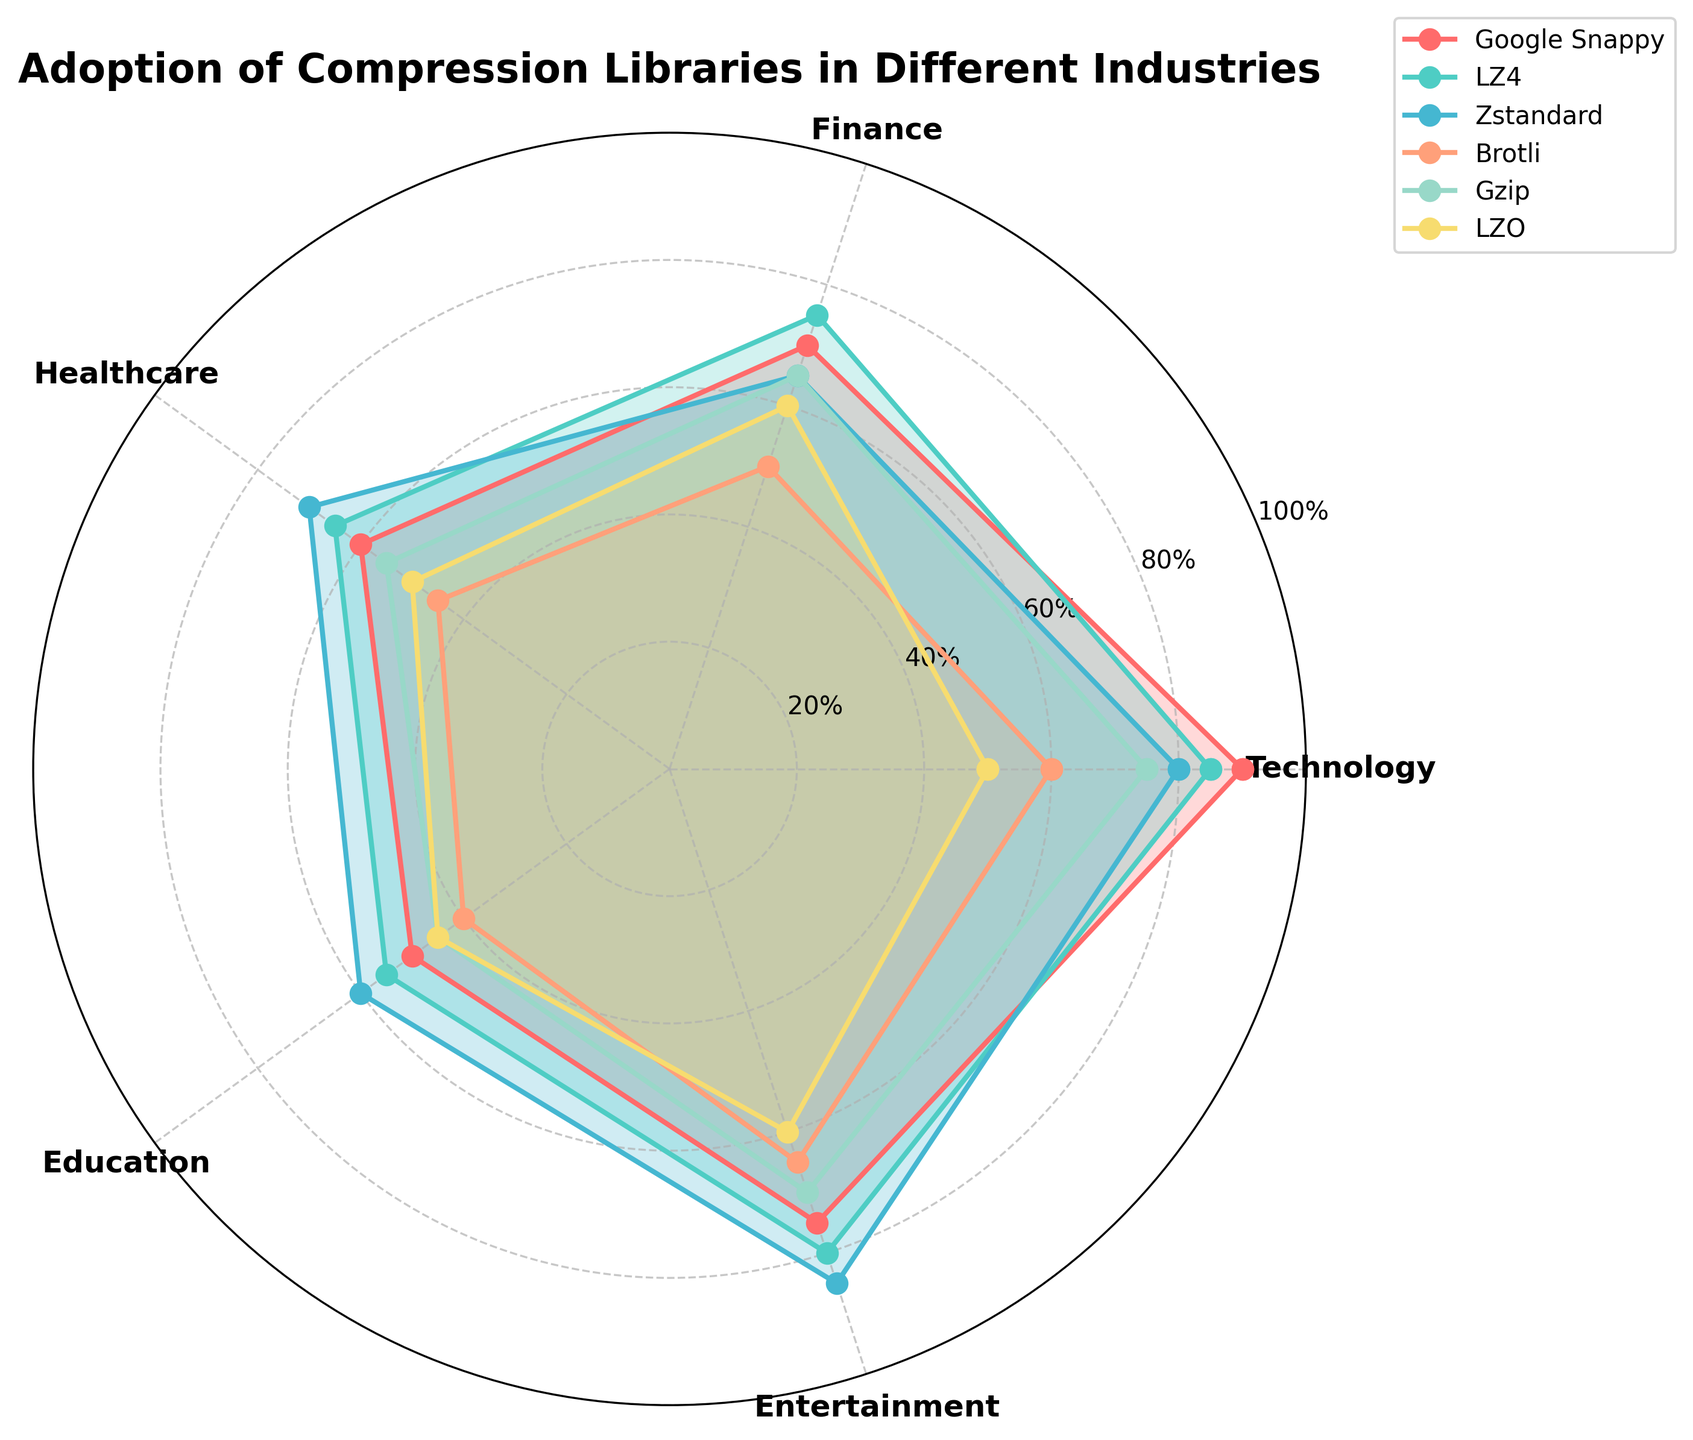What are the industries shown on the radar chart? The radar chart includes labels for each industry around the outer edge. These are Technology, Finance, Healthcare, Education, and Entertainment.
Answer: Technology, Finance, Healthcare, Education, Entertainment Which compression library has the highest adoption in Entertainment? By observing the outermost points within the Entertainment sector on the radar chart, we see that Zstandard has the highest value.
Answer: Zstandard What is the average adoption rate of Gzip across all industries? The values for Gzip are 75, 65, 55, 45, and 70. Adding these values gives 310. Dividing by the number of industries (5) results in an average adoption rate of 62.
Answer: 62 Compare the adoption of Brotli and LZO in Healthcare, which is higher? Viewing the Healthcare sector, Brotli has a value of 45 while LZO has a value of 50.
Answer: LZO Which compression library is least adopted in the Technology industry? Looking at the Technology axis, the smallest value is for LZO, which is 50.
Answer: LZO How much higher is the adoption rate of Google Snappy in Finance compared to Healthcare? The adoption rates are 70 in Finance and 60 in Healthcare for Google Snappy. The difference is 70 - 60 = 10.
Answer: 10 Which industrial sector has the closest adoption rates among all libraries? By examining the overlaps and consistency among all libraries, Education shows closely grouped adoption rates, around 40-60.
Answer: Education Is the adoption of LZ4 in Technology higher or lower than in Finance? The values for LZ4 are 85 in Technology and 75 in Finance, making it higher in Technology.
Answer: Higher What compression library has the most evenly distributed adoption rates across all industries? Analyzing the radial spread and consistency, LZ4 shows a relatively even distribution, with values ranging only from 55 to 85.
Answer: LZ4 